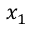Convert formula to latex. <formula><loc_0><loc_0><loc_500><loc_500>x _ { 1 }</formula> 